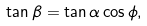Convert formula to latex. <formula><loc_0><loc_0><loc_500><loc_500>\tan \beta = \tan \alpha \cos \phi ,</formula> 